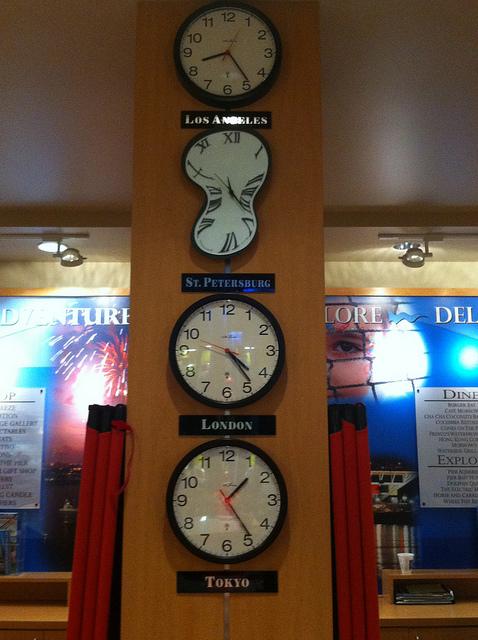Are these clocks all the same size and shape?
Short answer required. No. Are all the clocks set for the same time?
Short answer required. No. What number of clocks are on the wall?
Give a very brief answer. 4. 